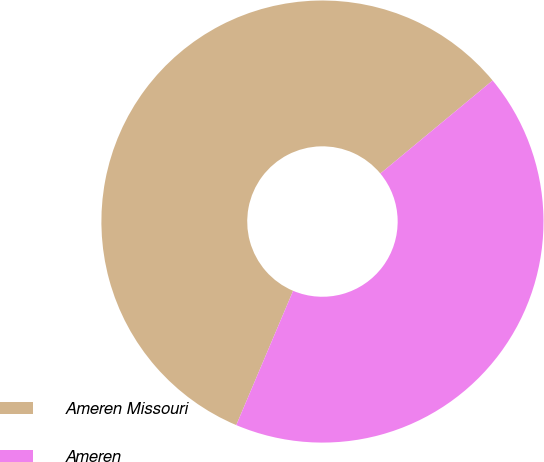Convert chart to OTSL. <chart><loc_0><loc_0><loc_500><loc_500><pie_chart><fcel>Ameren Missouri<fcel>Ameren<nl><fcel>57.61%<fcel>42.39%<nl></chart> 